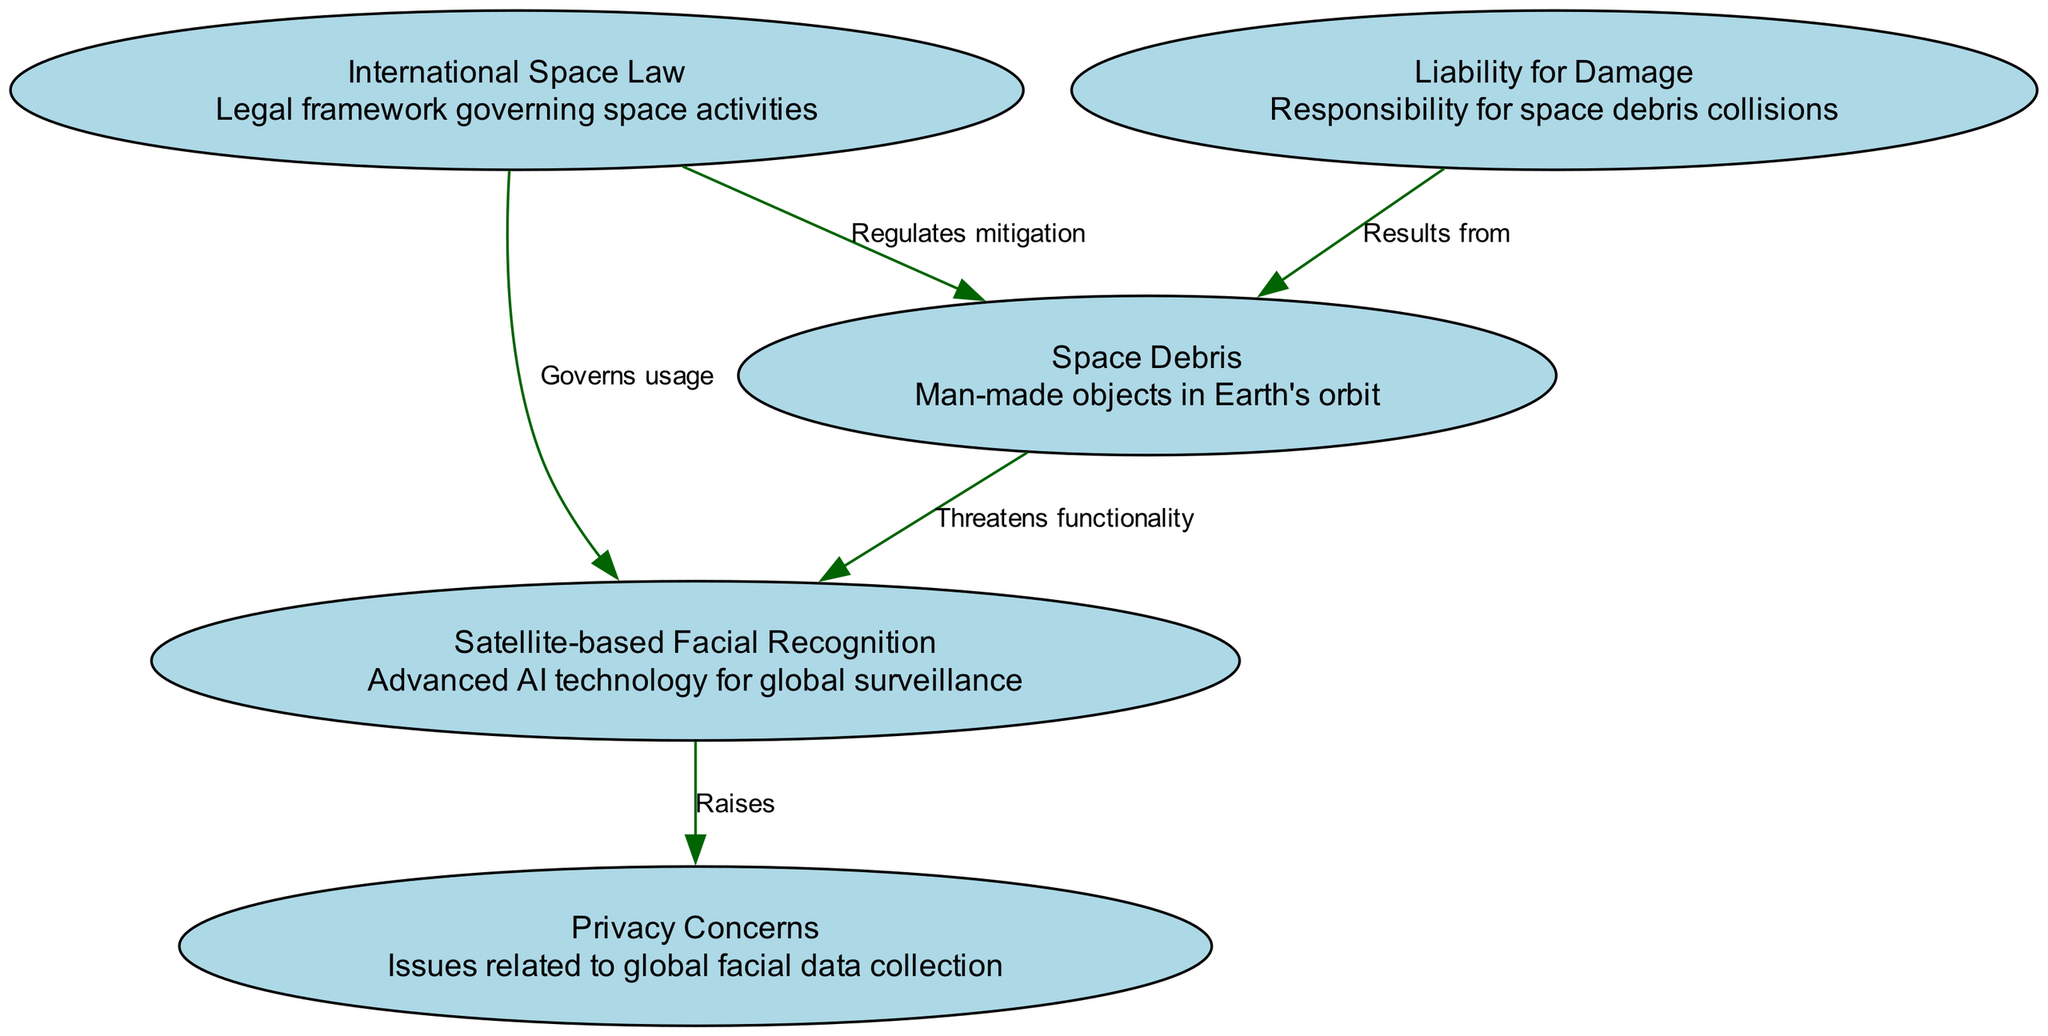What is the total number of nodes in the diagram? The diagram lists five nodes: Satellite-based Facial Recognition, Space Debris, International Space Law, Privacy Concerns, and Liability for Damage. Counting these gives a total of five nodes.
Answer: 5 Which node represents man-made objects in Earth's orbit? The node that describes man-made objects in Earth's orbit is "Space Debris." This information can be found in the description provided for that node.
Answer: Space Debris What relationship does International Space Law have with Space Debris? The edge leading from "International Space Law" to "Space Debris" indicates that it "Regulates mitigation." This means that it governs the actions taken to reduce space debris.
Answer: Regulates mitigation How many edges are present in the diagram? The diagram has five edges that indicate the relationships between nodes: one from Space Debris to Satellite-based Facial Recognition, one from International Space Law to Space Debris, one from International Space Law to Satellite-based Facial Recognition, one from Satellite-based Facial Recognition to Privacy Concerns, and one from Liability for Damage to Space Debris. Counting these gives a total of five edges.
Answer: 5 What does Satellite-based Facial Recognition raise in terms of concerns? The connection from "Satellite-based Facial Recognition" to "Privacy Concerns" specifies that it "Raises" issues related to the collection of facial data on a global scale. This indicates a legal and ethical concern about privacy.
Answer: Raises What is the implication of Liability for Damage in relation to Space Debris? The edge from "Liability for Damage" to "Space Debris" states that it "Results from" collisions involving space debris. This implies that there is a legal responsibility associated with damages caused by space debris.
Answer: Results from What legal framework governs the usage of Satellite-based Facial Recognition? The edge from "International Space Law" to "Satellite-based Facial Recognition" indicates that this law "Governs usage," meaning it provides the legal framework within which satellite-based facial recognition operations are conducted.
Answer: Governs usage Which node describes issues related to global facial data collection? The node that describes issues related to global facial data collection is "Privacy Concerns," as indicated by its name and description in the diagram.
Answer: Privacy Concerns 